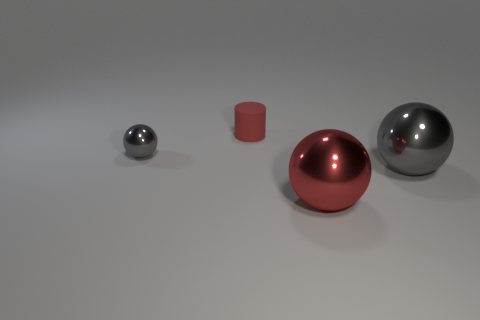Subtract all red metal balls. How many balls are left? 2 Subtract all red balls. How many balls are left? 2 Subtract all balls. How many objects are left? 1 Add 3 large purple matte blocks. How many objects exist? 7 Subtract all green cylinders. Subtract all gray spheres. How many cylinders are left? 1 Subtract all green cylinders. How many gray balls are left? 2 Subtract all big red balls. Subtract all tiny things. How many objects are left? 1 Add 4 metallic spheres. How many metallic spheres are left? 7 Add 3 small gray metal spheres. How many small gray metal spheres exist? 4 Subtract 0 purple spheres. How many objects are left? 4 